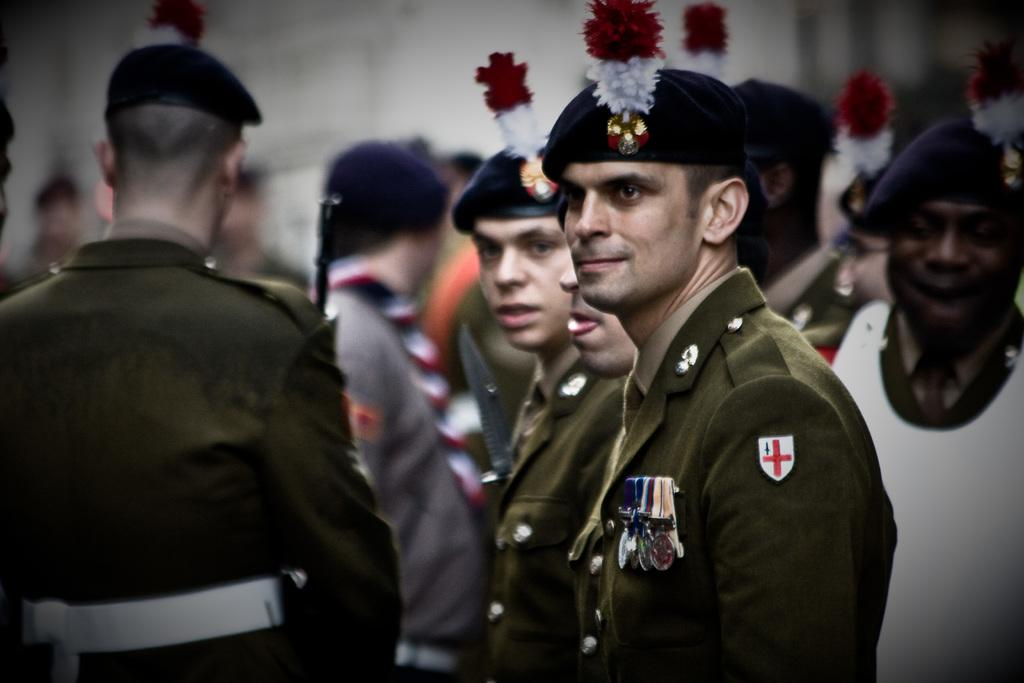Who or what can be seen in the image? There are people in the image. What are the people doing in the image? The people are standing. What are the people wearing on their heads in the image? The people are wearing caps. What type of behavior does the robin exhibit in the image? There is no robin present in the image, so it is not possible to determine its behavior. 